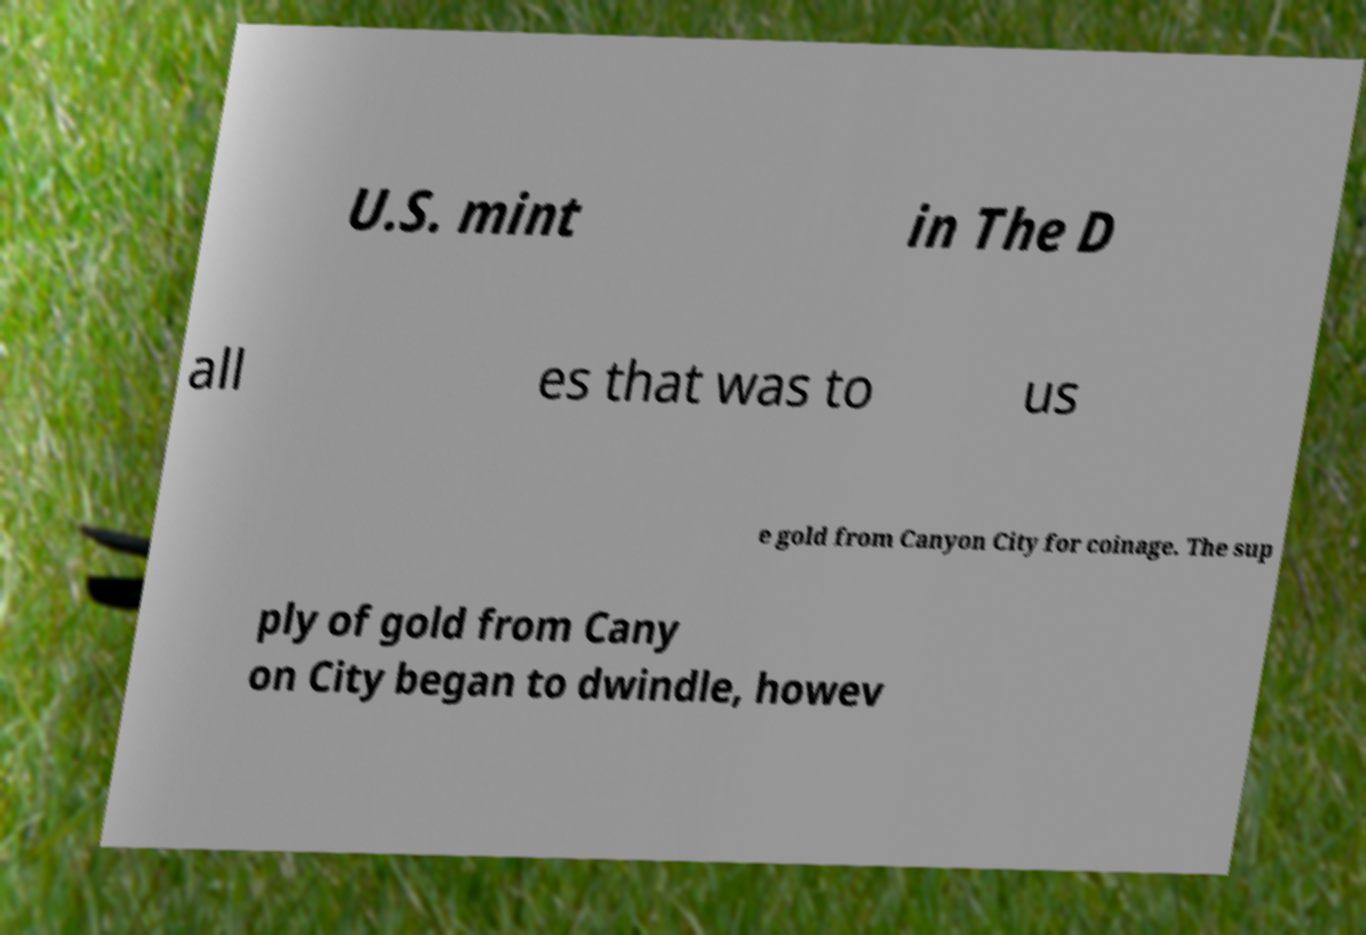Can you accurately transcribe the text from the provided image for me? U.S. mint in The D all es that was to us e gold from Canyon City for coinage. The sup ply of gold from Cany on City began to dwindle, howev 